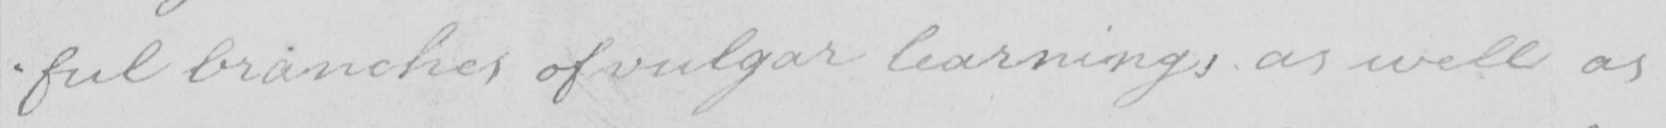What is written in this line of handwriting? -ful branches of vulgar learnings as well as 